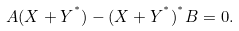<formula> <loc_0><loc_0><loc_500><loc_500>A ( X + Y ^ { ^ { * } } ) - ( X + Y ^ { ^ { * } } ) ^ { ^ { * } } B = 0 .</formula> 